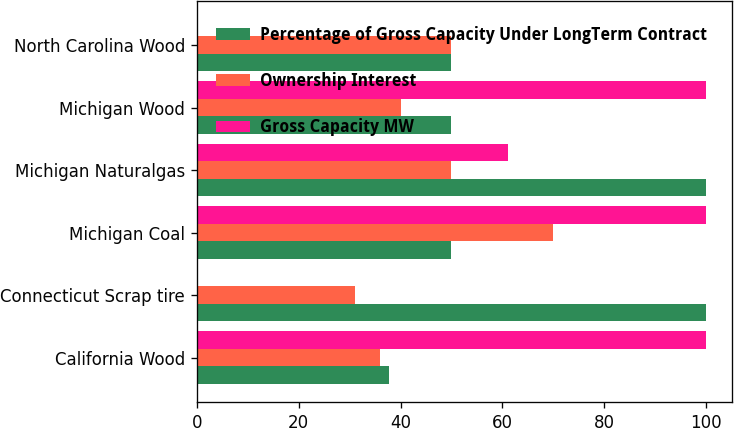<chart> <loc_0><loc_0><loc_500><loc_500><stacked_bar_chart><ecel><fcel>California Wood<fcel>Connecticut Scrap tire<fcel>Michigan Coal<fcel>Michigan Naturalgas<fcel>Michigan Wood<fcel>North Carolina Wood<nl><fcel>Percentage of Gross Capacity Under LongTerm Contract<fcel>37.8<fcel>100<fcel>50<fcel>100<fcel>50<fcel>50<nl><fcel>Ownership Interest<fcel>36<fcel>31<fcel>70<fcel>50<fcel>40<fcel>50<nl><fcel>Gross Capacity MW<fcel>100<fcel>0<fcel>100<fcel>61<fcel>100<fcel>0<nl></chart> 